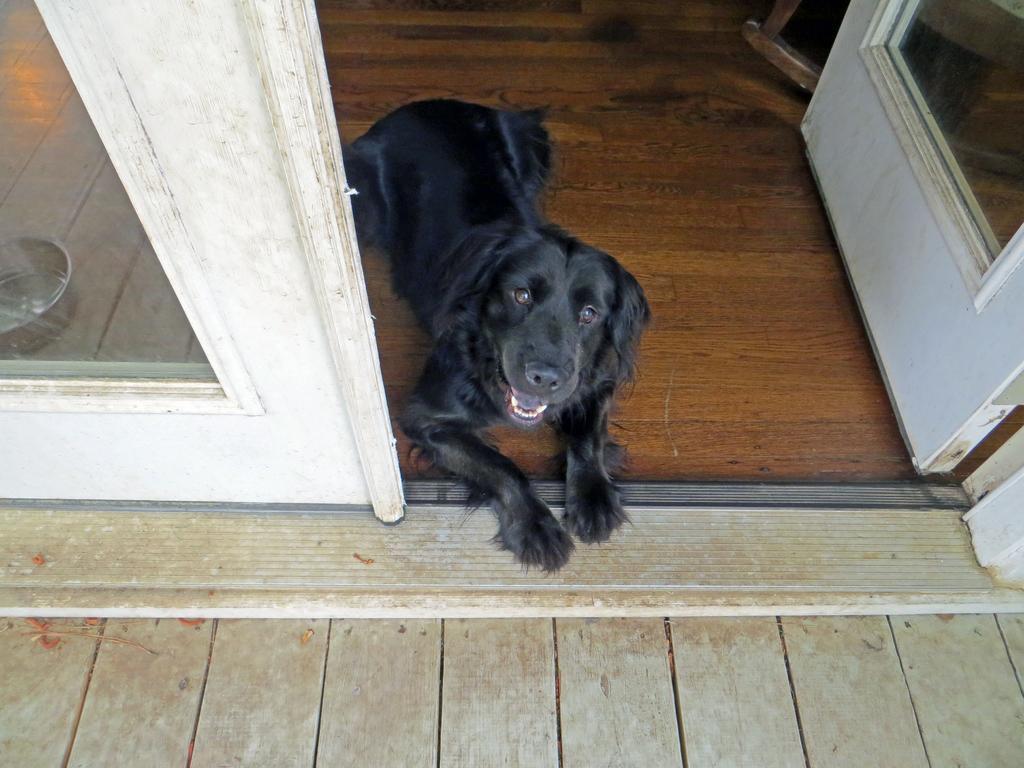How would you summarize this image in a sentence or two? In the image we can see a dog, black in color. Here we can see the container, wooden floor and the door. 